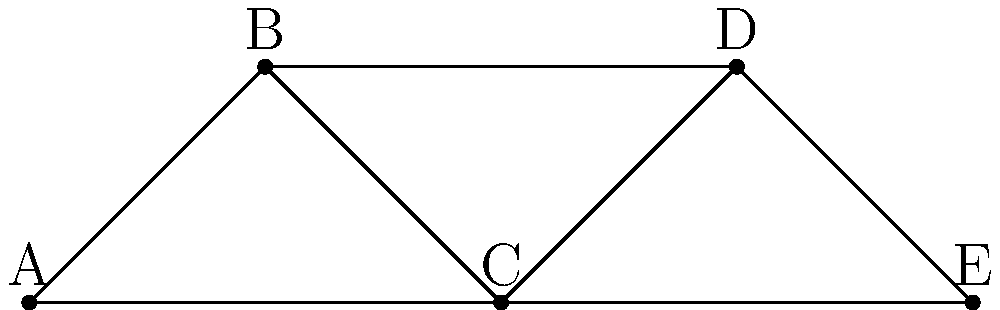Consider the network represented by the graph above, where nodes represent influential women during the Enlightenment period. What is the vertex connectivity of this graph, and what does it imply about the network's resilience? To determine the vertex connectivity of the graph and understand its implications for network resilience, we'll follow these steps:

1. Definition: The vertex connectivity of a graph is the minimum number of vertices that need to be removed to disconnect the graph.

2. Analyze the graph:
   a. The graph has 5 vertices (A, B, C, D, E).
   b. It is connected, as there is a path between any pair of vertices.

3. Consider possible vertex removals:
   a. Removing any single vertex does not disconnect the graph.
   b. Removing vertices A and E leaves B, C, and D connected.
   c. Removing vertices B and D leaves A, C, and E connected.
   d. Removing vertices A and C disconnects the graph into two components: {B, D} and {E}.

4. Conclusion: The minimum number of vertices that need to be removed to disconnect the graph is 2.

5. Implication for network resilience:
   a. A vertex connectivity of 2 means the network is 2-connected.
   b. This implies that the network of influential women during the Enlightenment is relatively resilient.
   c. It would take the removal of at least two key figures to disrupt the flow of ideas and influence within the network.
   d. However, it's not maximally resilient, as there are critical pairs of women whose removal would fragment the network.
Answer: 2; moderately resilient network 